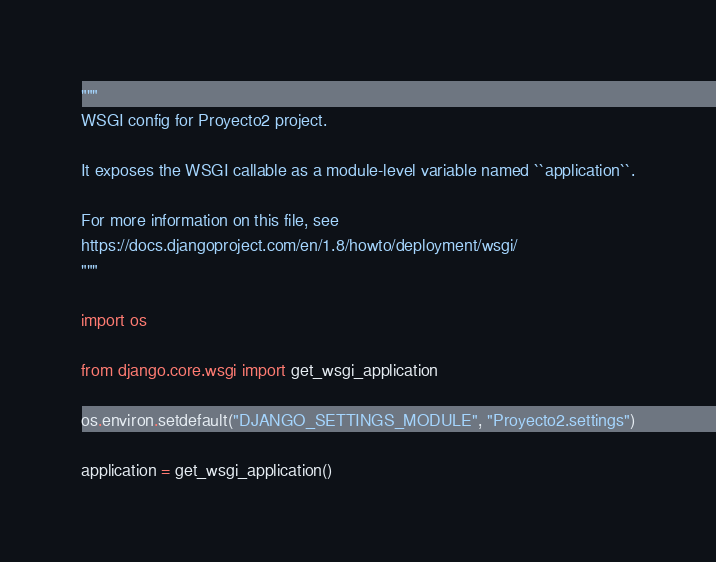Convert code to text. <code><loc_0><loc_0><loc_500><loc_500><_Python_>"""
WSGI config for Proyecto2 project.

It exposes the WSGI callable as a module-level variable named ``application``.

For more information on this file, see
https://docs.djangoproject.com/en/1.8/howto/deployment/wsgi/
"""

import os

from django.core.wsgi import get_wsgi_application

os.environ.setdefault("DJANGO_SETTINGS_MODULE", "Proyecto2.settings")

application = get_wsgi_application()
</code> 